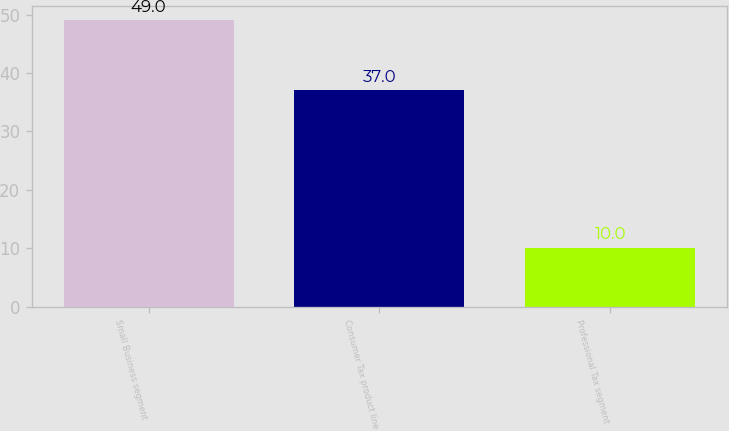Convert chart. <chart><loc_0><loc_0><loc_500><loc_500><bar_chart><fcel>Small Business segment<fcel>Consumer Tax product line<fcel>Professional Tax segment<nl><fcel>49<fcel>37<fcel>10<nl></chart> 